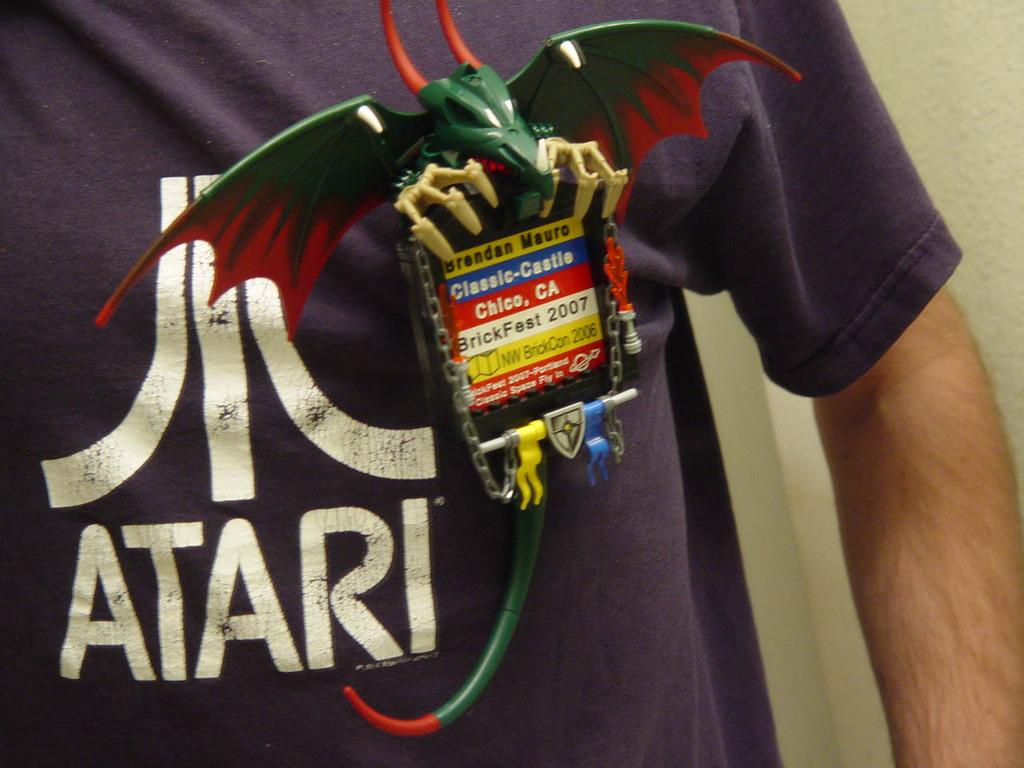<image>
Render a clear and concise summary of the photo. A dragon pin is warn on a blue Atari shirt. 